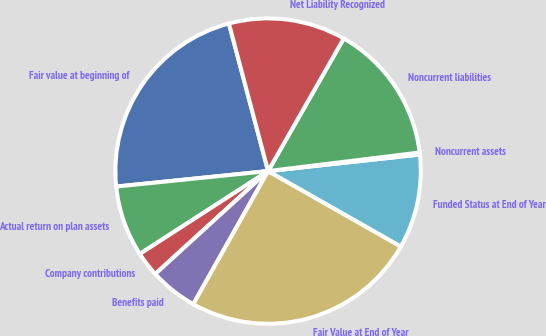Convert chart. <chart><loc_0><loc_0><loc_500><loc_500><pie_chart><fcel>Fair value at beginning of<fcel>Actual return on plan assets<fcel>Company contributions<fcel>Benefits paid<fcel>Fair Value at End of Year<fcel>Funded Status at End of Year<fcel>Noncurrent assets<fcel>Noncurrent liabilities<fcel>Net Liability Recognized<nl><fcel>22.49%<fcel>7.51%<fcel>2.64%<fcel>5.08%<fcel>24.93%<fcel>9.95%<fcel>0.21%<fcel>14.81%<fcel>12.38%<nl></chart> 